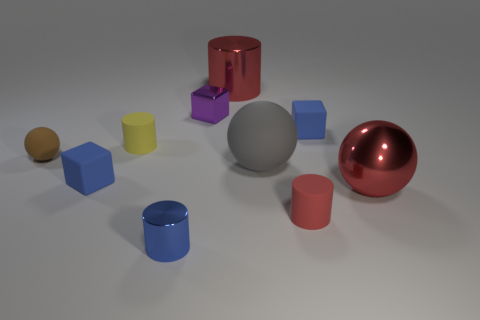How many gray matte blocks are there?
Your answer should be very brief. 0. How many small blue objects are the same material as the tiny purple cube?
Provide a short and direct response. 1. Are there an equal number of big matte things that are to the right of the big red ball and rubber blocks?
Your response must be concise. No. There is another cylinder that is the same color as the big shiny cylinder; what is it made of?
Give a very brief answer. Rubber. There is a gray sphere; does it have the same size as the red shiny thing that is in front of the yellow matte thing?
Make the answer very short. Yes. What number of other objects are there of the same size as the blue metallic thing?
Provide a short and direct response. 6. How many other things are there of the same color as the big metal cylinder?
Provide a succinct answer. 2. Are there any other things that are the same size as the gray ball?
Provide a short and direct response. Yes. What number of other things are the same shape as the big gray matte thing?
Your answer should be compact. 2. Does the yellow cylinder have the same size as the blue metallic cylinder?
Your answer should be very brief. Yes. 